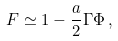Convert formula to latex. <formula><loc_0><loc_0><loc_500><loc_500>F \simeq 1 - \frac { a } { 2 } \Gamma \Phi \, ,</formula> 